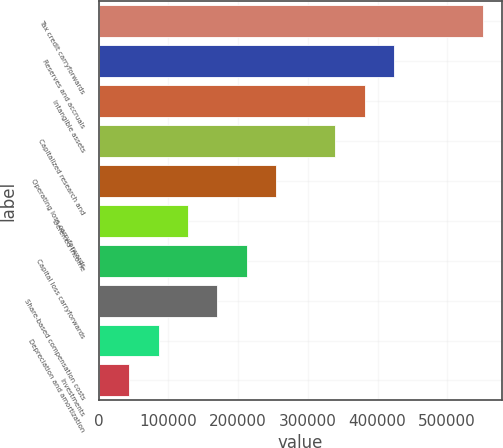Convert chart. <chart><loc_0><loc_0><loc_500><loc_500><bar_chart><fcel>Tax credit carryforwards<fcel>Reserves and accruals<fcel>Intangible assets<fcel>Capitalized research and<fcel>Operating loss carryforwards<fcel>Deferred income<fcel>Capital loss carryforwards<fcel>Share-based compensation costs<fcel>Depreciation and amortization<fcel>Investments<nl><fcel>550716<fcel>423935<fcel>381675<fcel>339414<fcel>254894<fcel>128113<fcel>212634<fcel>170373<fcel>85852.6<fcel>43592.3<nl></chart> 